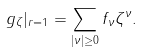<formula> <loc_0><loc_0><loc_500><loc_500>g _ { \zeta } | _ { r = 1 } = \sum _ { | \nu | \geq 0 } f _ { \nu } \zeta ^ { \nu } .</formula> 